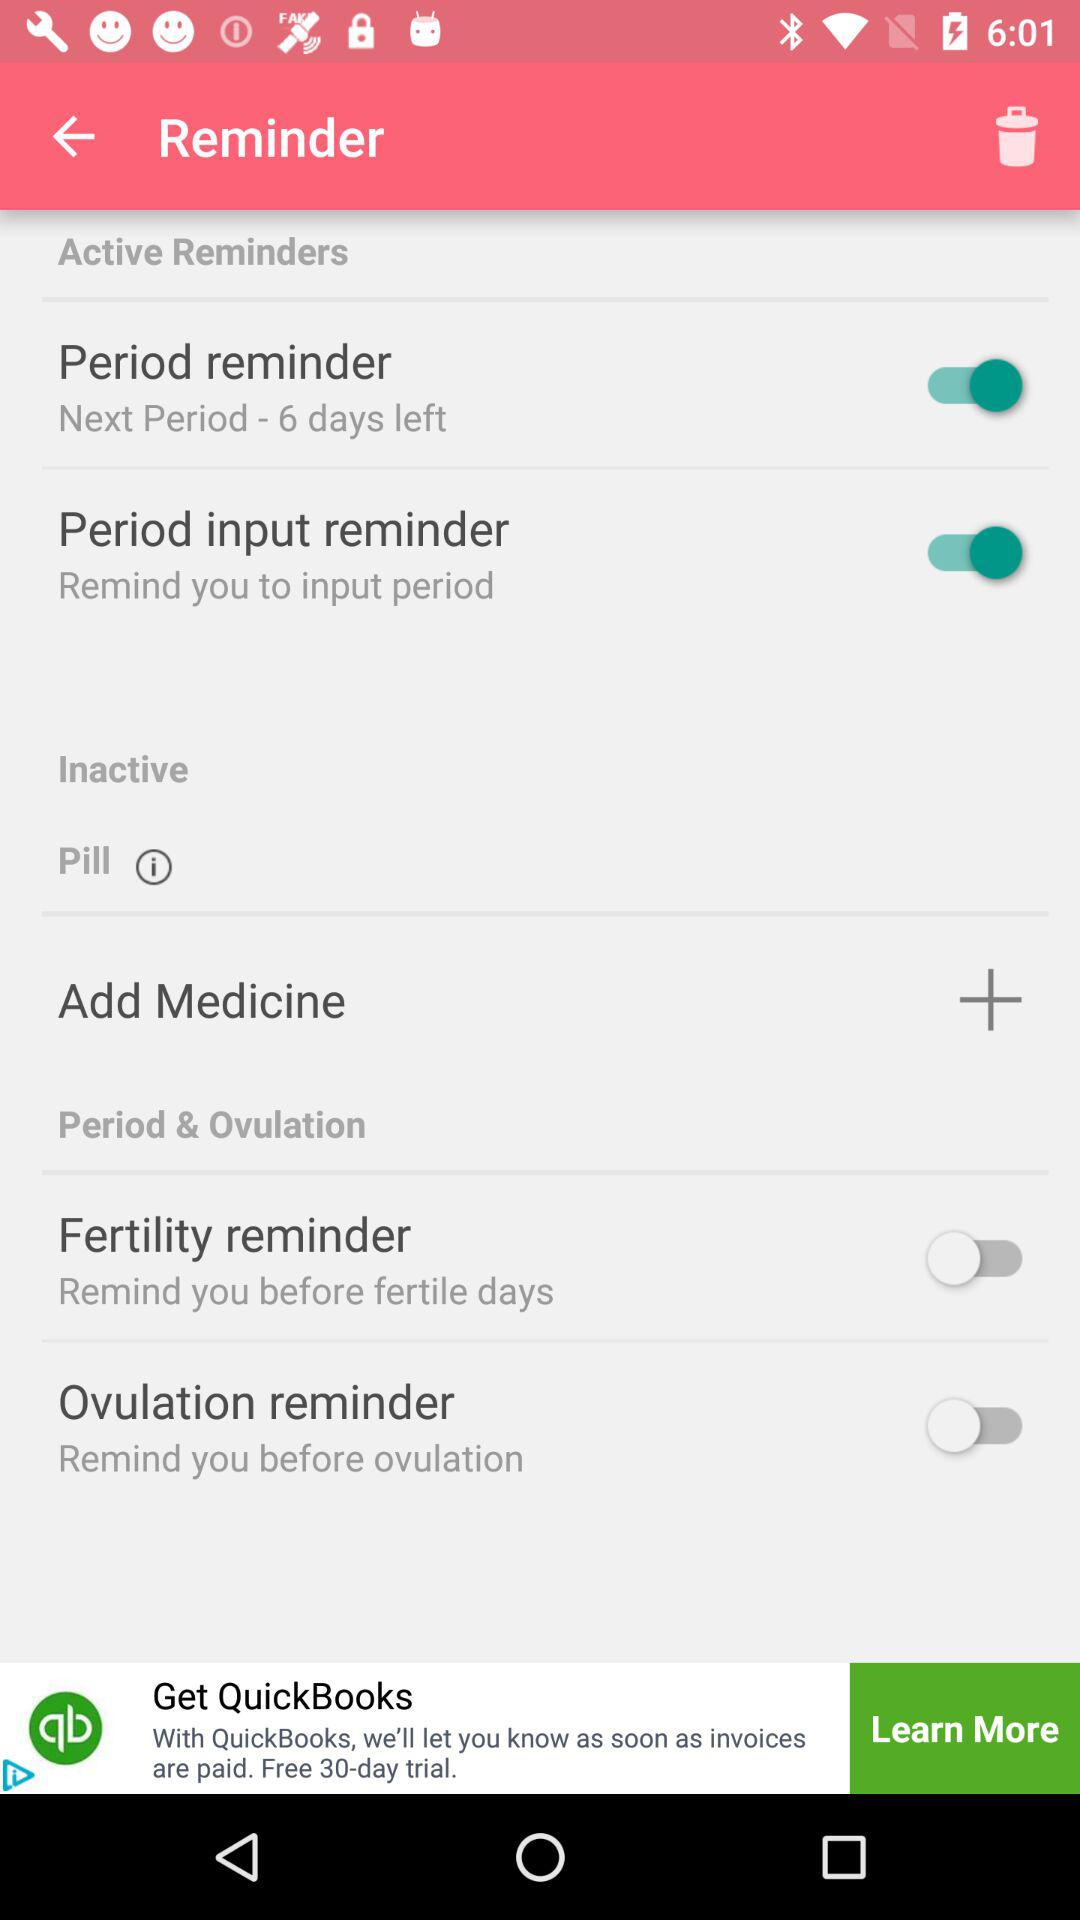How many days are left in the next period? There are 6 days left in the next period. 